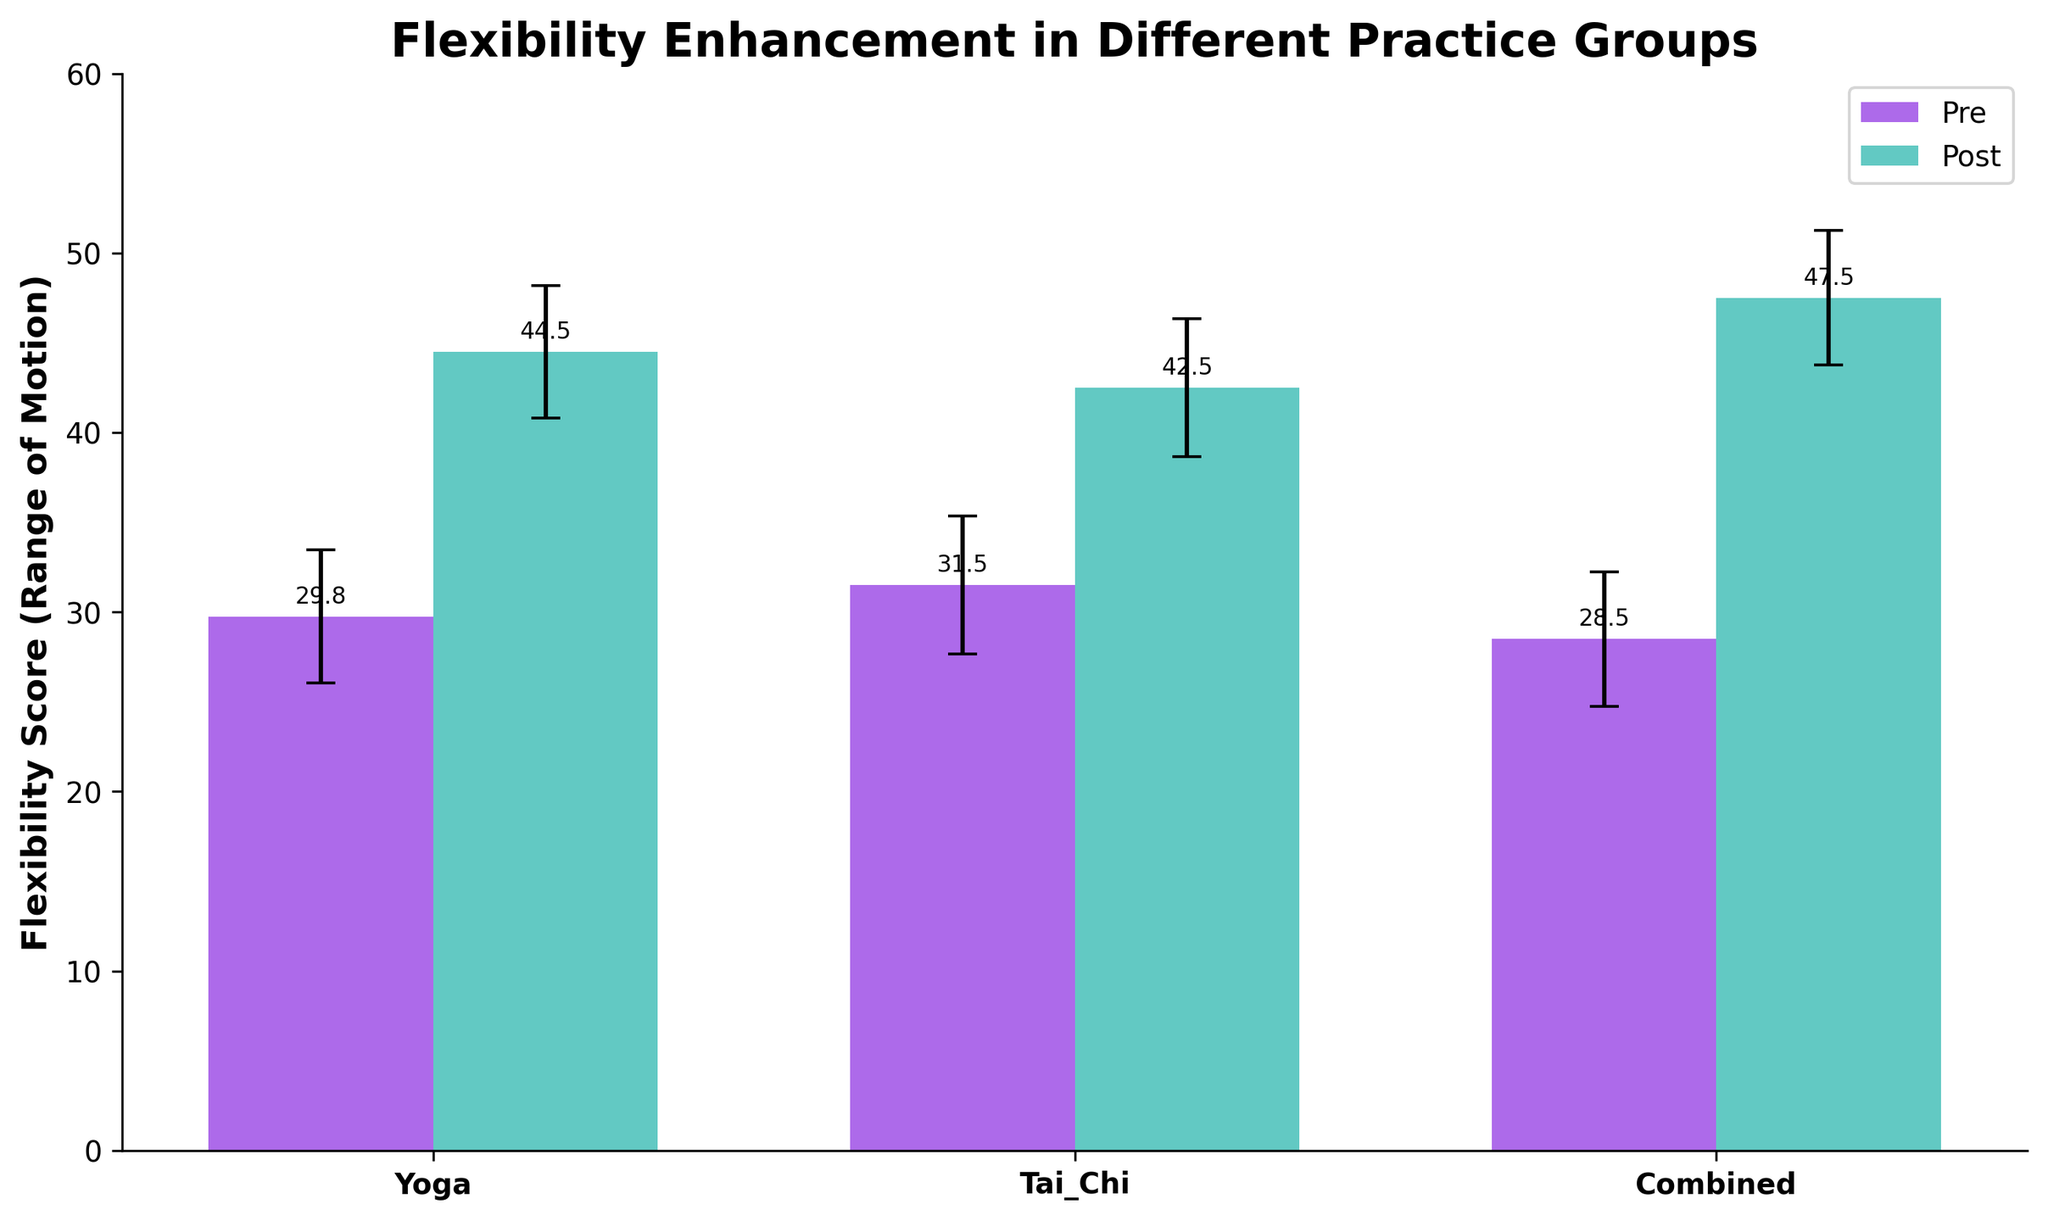What is the title of the plot? The title is located at the top of the plot. It describes the purpose of the figure.
Answer: Flexibility Enhancement in Different Practice Groups Which practice group shows the highest post-flexibility score? The highest post-flexibility score is identified by looking at the tallest bar among the 'Post' bars.
Answer: Combined What are the average pre-flexibility scores for each practice group? By observing the 'Pre' bars for each group and noting their heights, we can determine the average scores. For Yoga, it's about 29.75, for Tai Chi, it's about 31.5, and for Combined, it's about 28.5.
Answer: Yoga: 29.75, Tai Chi: 31.5, Combined: 28.5 Which practice group has the smallest error bar in the post-flexibility scores? Error bars depict the confidence intervals. The smallest error bar has the shortest vertical line above and below the bar.
Answer: Yoga How does the increase in flexibility score compare between Yoga and Tai Chi practice groups? Calculate the difference between pre and post scores for each group and compare them. Yoga increases by approximately 14.5 (45-30.5), and Tai Chi by about 10.25 (42.75-32.5).
Answer: Yoga: 14.5, Tai Chi: 10.25 What is the average post-flexibility score for the Combined practice group? Find the height of the post-flexibility bar for the Combined group.
Answer: 47.5 What is the standard deviation for the pre-flexibility scores in the Tai Chi group? The standard deviation is indicated by the length of the error bars. Check the error bar length for the pre-flexibility Tai Chi bars.
Answer: Approx. 3.85 Which practice group's flexibility score changed the most? Calculate the difference between the post and pre scores for each group and identify the maximum. Combined has the highest change: around 19 (47.5-28.5).
Answer: Combined How does the average post-flexibility score for Yoga compare to Tai Chi? Compare the height of the post-flexibility bars between Yoga and Tai Chi. Yoga's post-score is higher by about 2-3 points.
Answer: Yoga > Tai Chi What is the range of the confidence interval for the Yoga post-flexibility score? Observe the top and bottom ends of the error bar for Yoga's post-flexibility bar.
Answer: Approx. ±4.35 